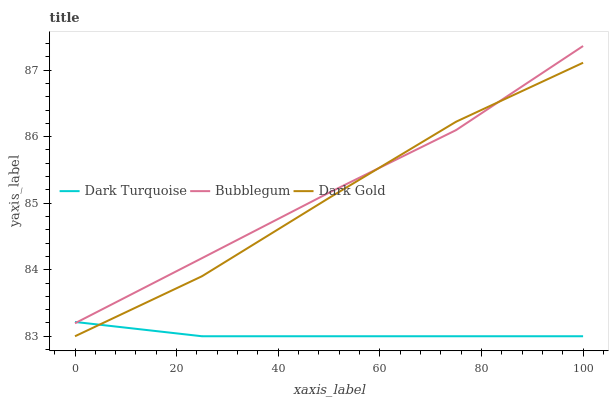Does Dark Turquoise have the minimum area under the curve?
Answer yes or no. Yes. Does Bubblegum have the maximum area under the curve?
Answer yes or no. Yes. Does Dark Gold have the minimum area under the curve?
Answer yes or no. No. Does Dark Gold have the maximum area under the curve?
Answer yes or no. No. Is Dark Turquoise the smoothest?
Answer yes or no. Yes. Is Dark Gold the roughest?
Answer yes or no. Yes. Is Bubblegum the smoothest?
Answer yes or no. No. Is Bubblegum the roughest?
Answer yes or no. No. Does Dark Turquoise have the lowest value?
Answer yes or no. Yes. Does Bubblegum have the lowest value?
Answer yes or no. No. Does Bubblegum have the highest value?
Answer yes or no. Yes. Does Dark Gold have the highest value?
Answer yes or no. No. Does Bubblegum intersect Dark Gold?
Answer yes or no. Yes. Is Bubblegum less than Dark Gold?
Answer yes or no. No. Is Bubblegum greater than Dark Gold?
Answer yes or no. No. 